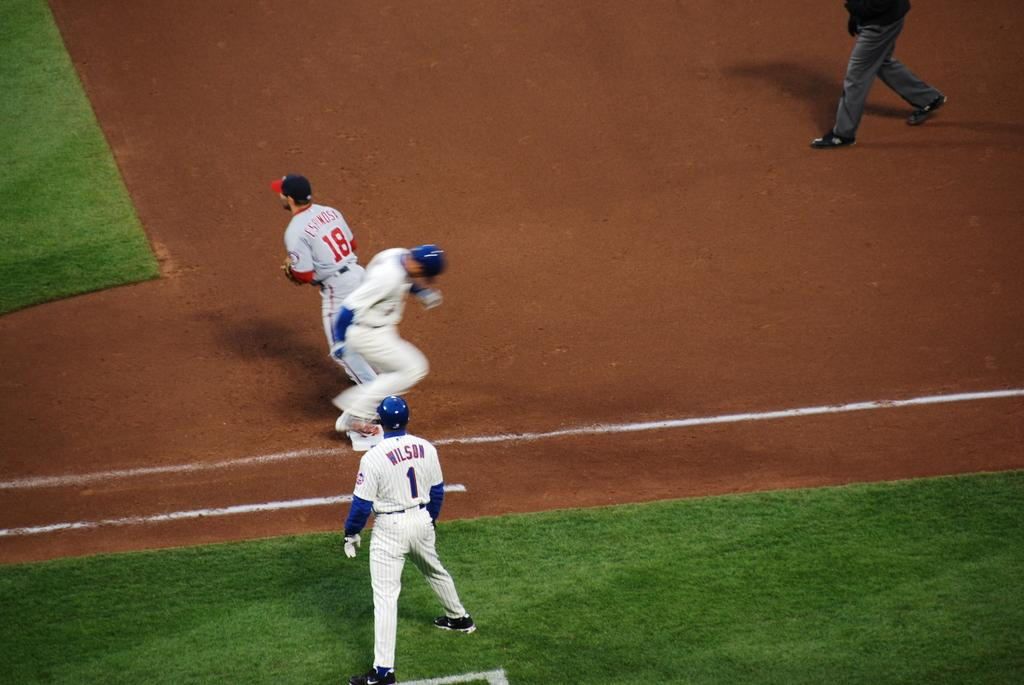Provide a one-sentence caption for the provided image. A baseball player runs onto first base while the first baseman waits for the ball. 